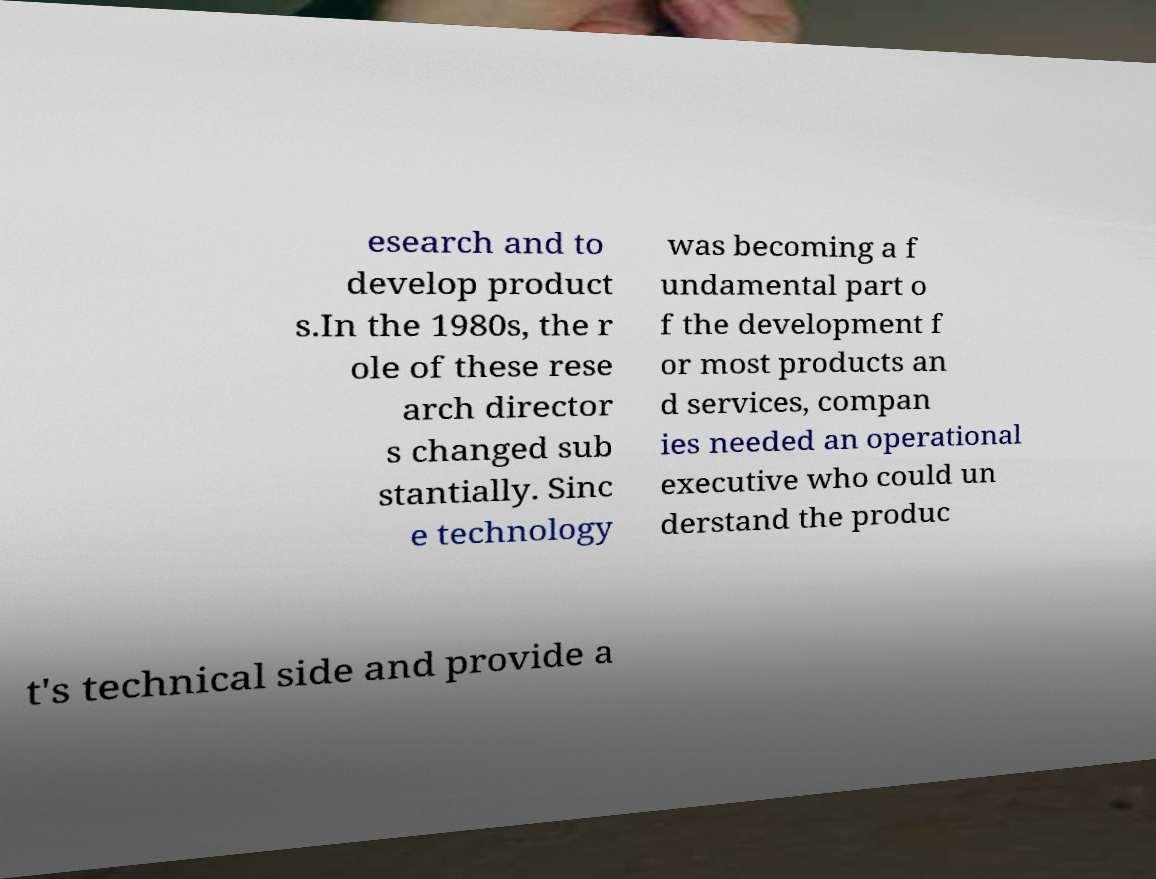Please read and relay the text visible in this image. What does it say? esearch and to develop product s.In the 1980s, the r ole of these rese arch director s changed sub stantially. Sinc e technology was becoming a f undamental part o f the development f or most products an d services, compan ies needed an operational executive who could un derstand the produc t's technical side and provide a 